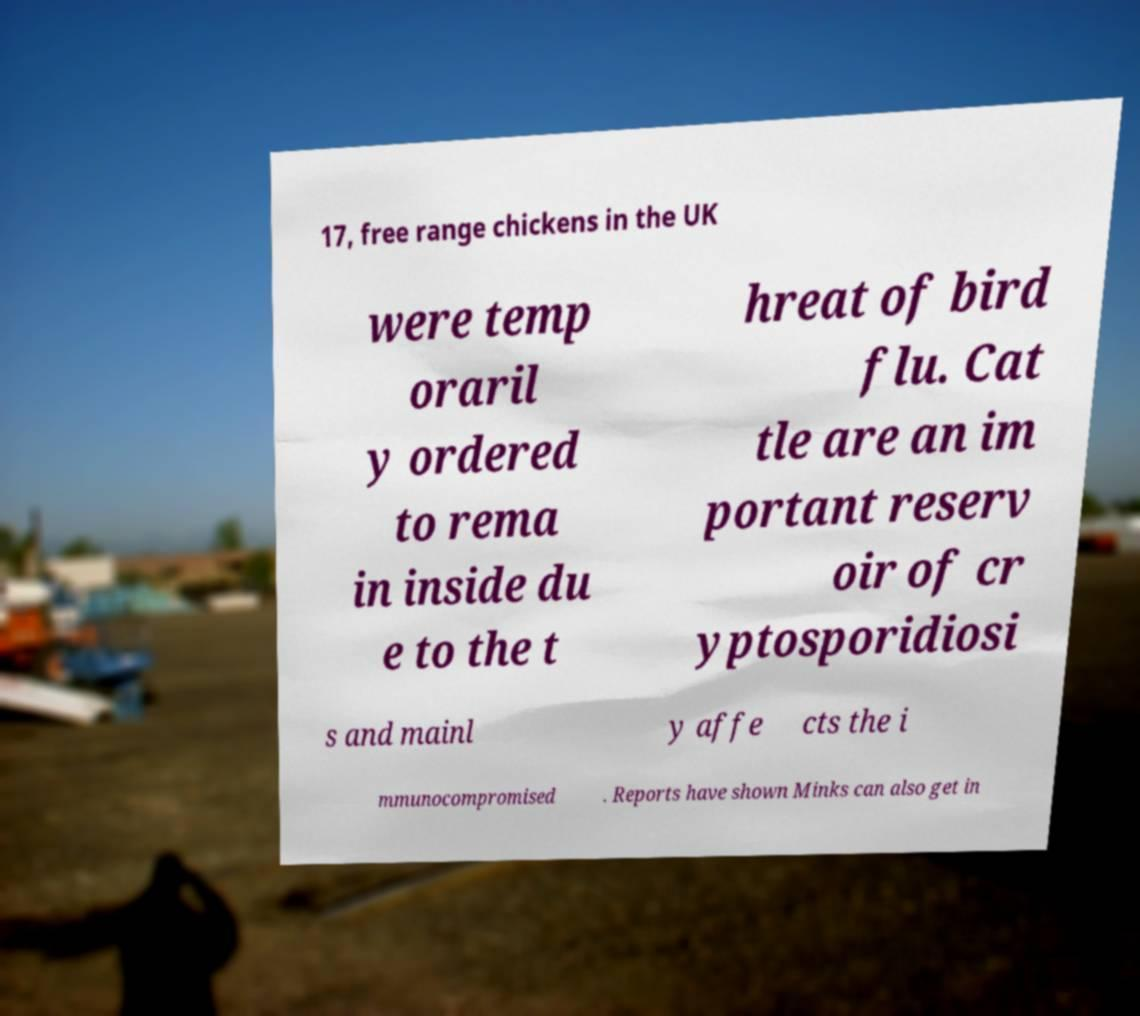Could you assist in decoding the text presented in this image and type it out clearly? 17, free range chickens in the UK were temp oraril y ordered to rema in inside du e to the t hreat of bird flu. Cat tle are an im portant reserv oir of cr yptosporidiosi s and mainl y affe cts the i mmunocompromised . Reports have shown Minks can also get in 